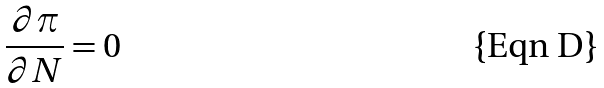Convert formula to latex. <formula><loc_0><loc_0><loc_500><loc_500>\frac { \partial \pi } { \partial N } = 0</formula> 